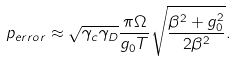<formula> <loc_0><loc_0><loc_500><loc_500>p _ { e r r o r } \approx \sqrt { \gamma _ { c } \gamma _ { D } } \frac { \pi \Omega } { g _ { 0 } T } \sqrt { \frac { \beta ^ { 2 } + g _ { 0 } ^ { 2 } } { 2 \beta ^ { 2 } } } .</formula> 